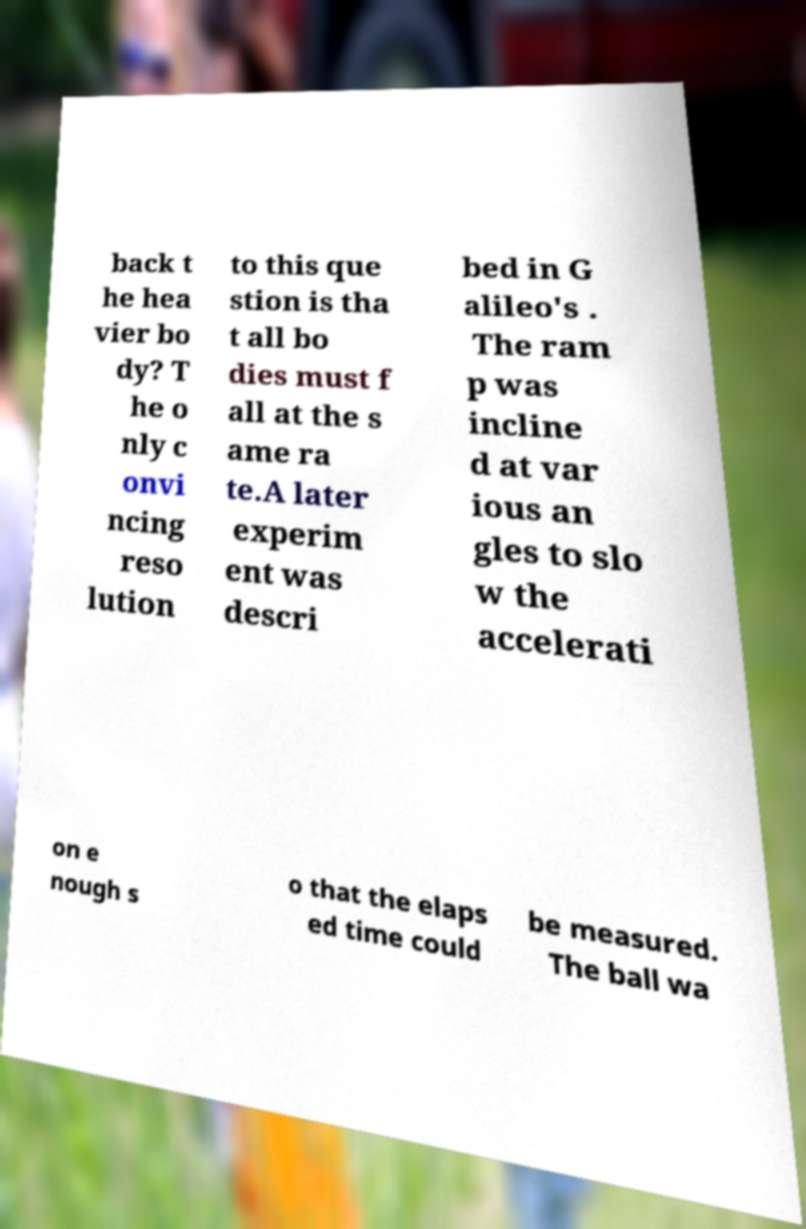Please identify and transcribe the text found in this image. back t he hea vier bo dy? T he o nly c onvi ncing reso lution to this que stion is tha t all bo dies must f all at the s ame ra te.A later experim ent was descri bed in G alileo's . The ram p was incline d at var ious an gles to slo w the accelerati on e nough s o that the elaps ed time could be measured. The ball wa 